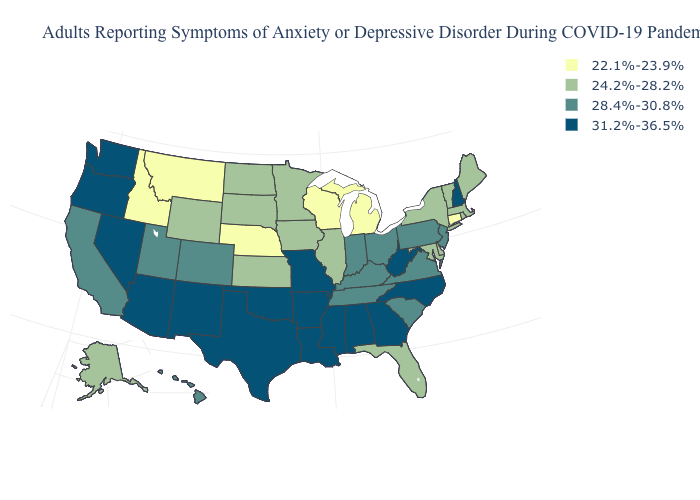What is the value of Massachusetts?
Answer briefly. 24.2%-28.2%. What is the value of New York?
Short answer required. 24.2%-28.2%. Name the states that have a value in the range 28.4%-30.8%?
Concise answer only. California, Colorado, Hawaii, Indiana, Kentucky, New Jersey, Ohio, Pennsylvania, South Carolina, Tennessee, Utah, Virginia. Name the states that have a value in the range 22.1%-23.9%?
Be succinct. Connecticut, Idaho, Michigan, Montana, Nebraska, Wisconsin. Name the states that have a value in the range 22.1%-23.9%?
Keep it brief. Connecticut, Idaho, Michigan, Montana, Nebraska, Wisconsin. What is the highest value in states that border Alabama?
Quick response, please. 31.2%-36.5%. What is the lowest value in the MidWest?
Quick response, please. 22.1%-23.9%. What is the highest value in states that border West Virginia?
Give a very brief answer. 28.4%-30.8%. Is the legend a continuous bar?
Give a very brief answer. No. Does Michigan have the lowest value in the USA?
Answer briefly. Yes. Name the states that have a value in the range 22.1%-23.9%?
Answer briefly. Connecticut, Idaho, Michigan, Montana, Nebraska, Wisconsin. What is the lowest value in the USA?
Keep it brief. 22.1%-23.9%. Name the states that have a value in the range 22.1%-23.9%?
Give a very brief answer. Connecticut, Idaho, Michigan, Montana, Nebraska, Wisconsin. Which states have the highest value in the USA?
Short answer required. Alabama, Arizona, Arkansas, Georgia, Louisiana, Mississippi, Missouri, Nevada, New Hampshire, New Mexico, North Carolina, Oklahoma, Oregon, Texas, Washington, West Virginia. Name the states that have a value in the range 24.2%-28.2%?
Keep it brief. Alaska, Delaware, Florida, Illinois, Iowa, Kansas, Maine, Maryland, Massachusetts, Minnesota, New York, North Dakota, Rhode Island, South Dakota, Vermont, Wyoming. 